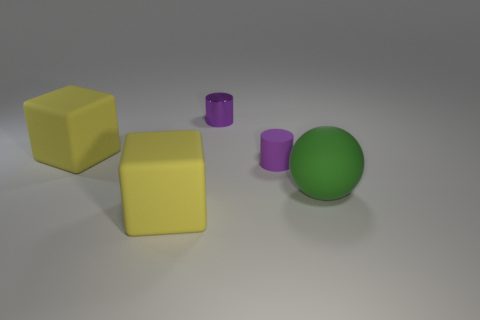Is the color of the metal thing the same as the large block behind the large green ball?
Give a very brief answer. No. There is a object that is both in front of the metallic cylinder and behind the rubber cylinder; what color is it?
Provide a short and direct response. Yellow. There is a yellow thing in front of the purple matte object; what number of big rubber objects are behind it?
Make the answer very short. 2. Is there another big object that has the same shape as the shiny object?
Provide a short and direct response. No. There is a small object that is in front of the metallic object; is it the same shape as the tiny purple object that is behind the tiny purple matte thing?
Provide a succinct answer. Yes. What number of objects are large blocks or small matte objects?
Your answer should be very brief. 3. Is the number of matte things that are in front of the tiny rubber cylinder greater than the number of small red matte objects?
Offer a very short reply. Yes. What number of things are either big yellow cubes that are behind the tiny purple rubber thing or large rubber objects that are behind the purple rubber thing?
Offer a terse response. 1. The matte thing that is the same shape as the purple metallic thing is what color?
Keep it short and to the point. Purple. How many small things have the same color as the matte cylinder?
Provide a short and direct response. 1. 